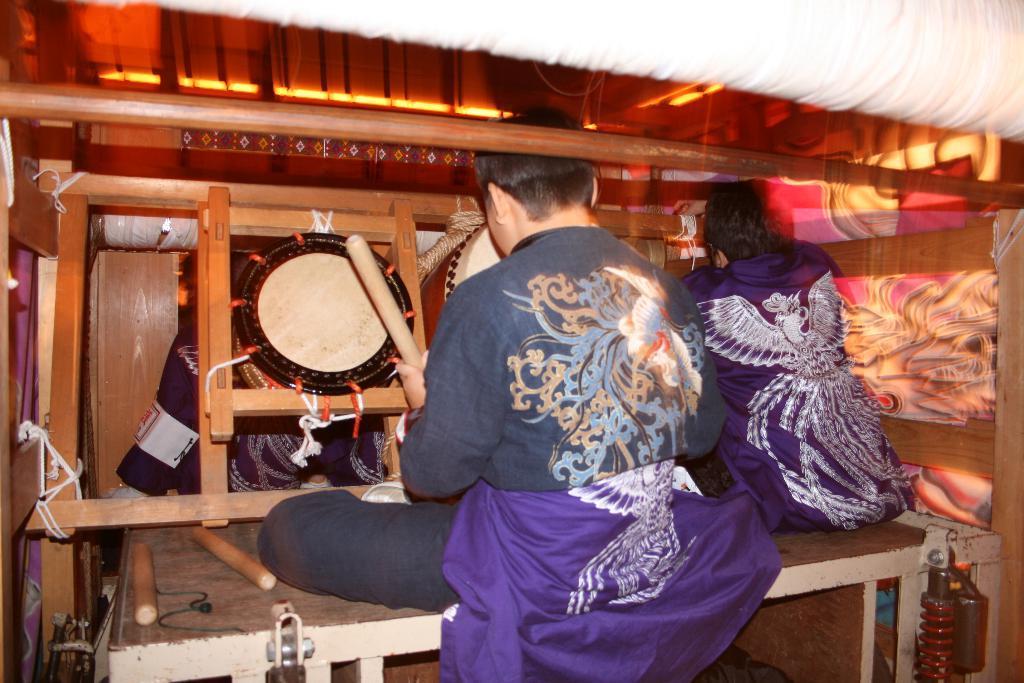In one or two sentences, can you explain what this image depicts? in this image i can see a person sit on the bench and wearing a blue color skirts and there is some wood in front of them and there is a art on the wall 